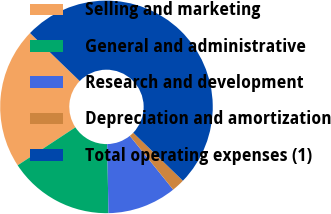Convert chart to OTSL. <chart><loc_0><loc_0><loc_500><loc_500><pie_chart><fcel>Selling and marketing<fcel>General and administrative<fcel>Research and development<fcel>Depreciation and amortization<fcel>Total operating expenses (1)<nl><fcel>21.49%<fcel>16.04%<fcel>10.5%<fcel>1.98%<fcel>50.0%<nl></chart> 